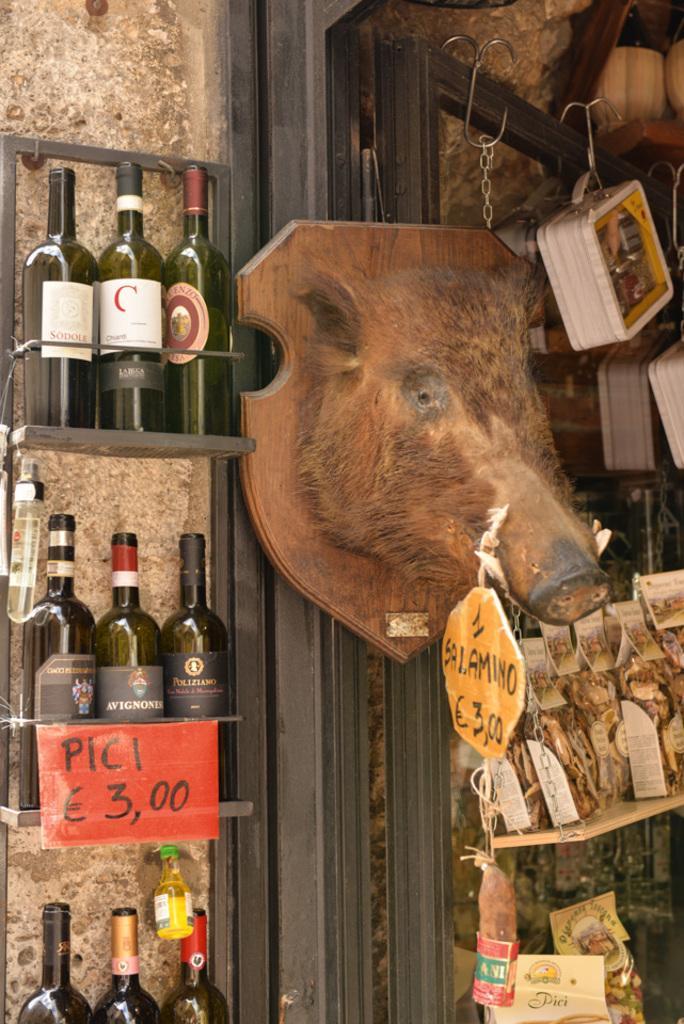Can you describe this image briefly? In this image we can see beverage bottles arranged in the cupboards, price tags, decor and serving trays hanged to the hooks. 